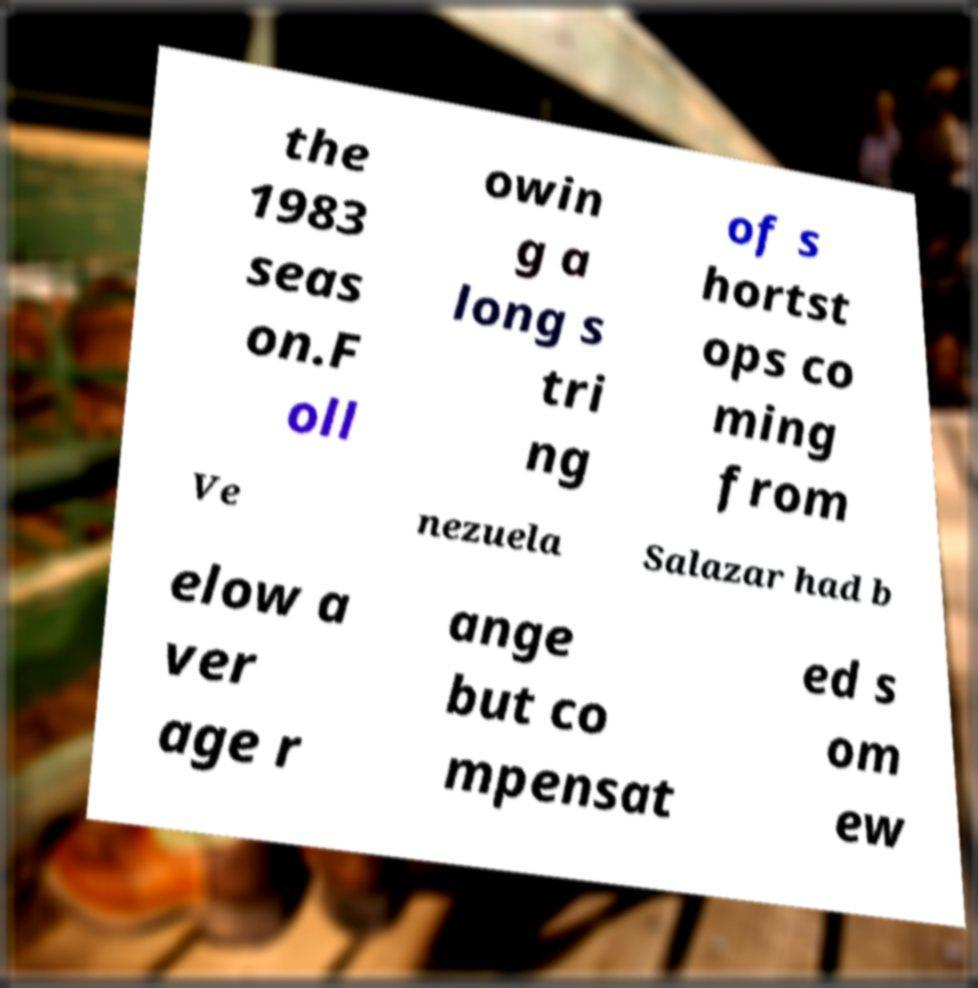Could you extract and type out the text from this image? the 1983 seas on.F oll owin g a long s tri ng of s hortst ops co ming from Ve nezuela Salazar had b elow a ver age r ange but co mpensat ed s om ew 